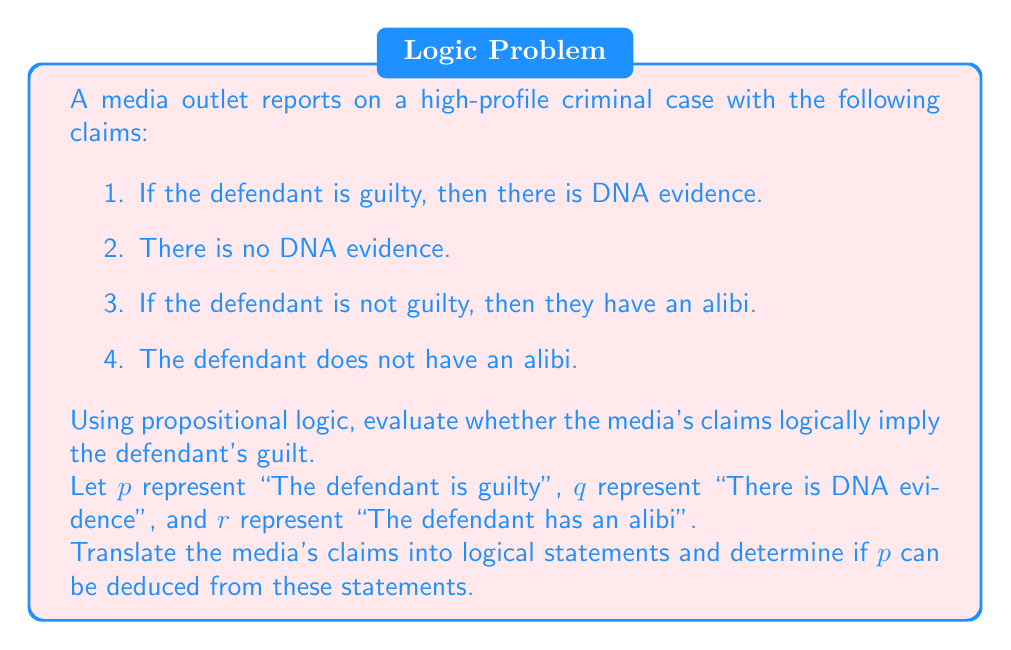Can you answer this question? Let's approach this step-by-step using propositional logic:

1. Translate the media's claims into logical statements:
   - Claim 1: $p \rightarrow q$
   - Claim 2: $\neg q$
   - Claim 3: $\neg p \rightarrow r$
   - Claim 4: $\neg r$

2. We want to determine if $p$ (defendant's guilt) can be logically deduced from these statements.

3. From claims 1 and 2, we can use modus tollens:
   $$(p \rightarrow q) \land \neg q \Rightarrow \neg p$$

4. From claims 3 and 4, we can also use modus tollens:
   $$(\neg p \rightarrow r) \land \neg r \Rightarrow \neg(\neg p) \Rightarrow p$$

5. We now have two contradictory conclusions: $\neg p$ and $p$

6. This contradiction indicates that the set of claims is inconsistent. In propositional logic, an inconsistent set of premises can imply any conclusion, including both $p$ and $\neg p$. This is known as the principle of explosion or ex falso quodlibet.

7. Therefore, while $p$ can be derived from these claims, so can $\neg p$, rendering any conclusion about the defendant's guilt or innocence logically unsound based solely on these claims.
Answer: The media's claims do not logically imply the defendant's guilt. The set of claims is inconsistent, leading to a contradiction. This inconsistency means that both guilt and innocence can be derived, making any conclusion about the defendant's guilt logically unsound based solely on these claims. 